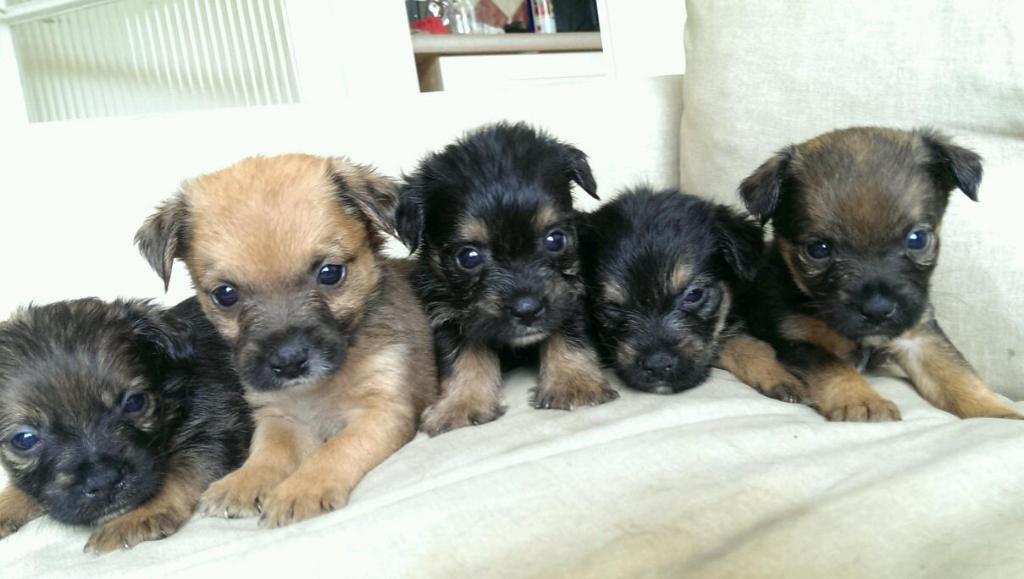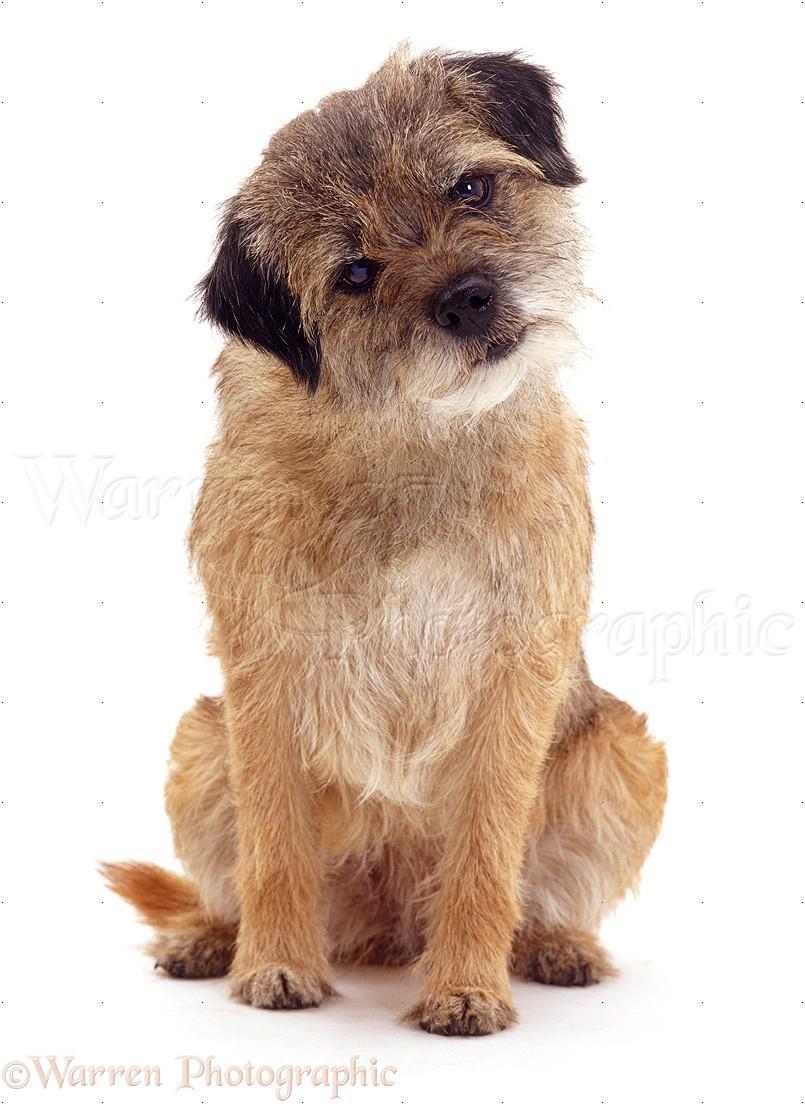The first image is the image on the left, the second image is the image on the right. Given the left and right images, does the statement "The combined images contain three dogs, and one image contains a pair of similarly-posed reclining dogs." hold true? Answer yes or no. No. 